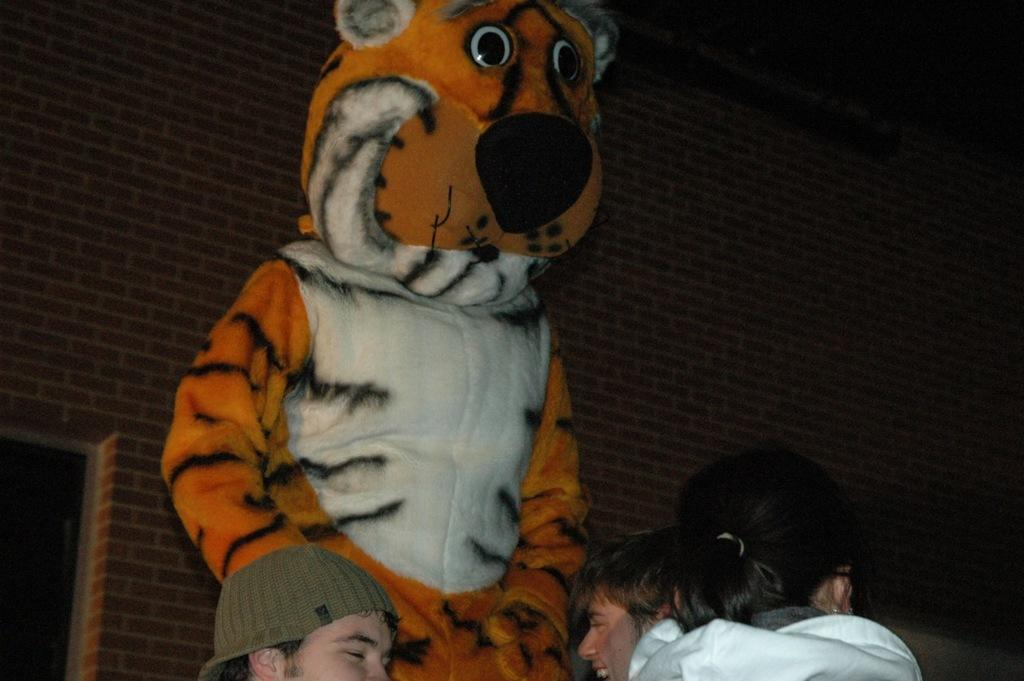What type of animal is in the image? There is a tiger in the image. Are there any people in the image? Yes, there is a woman and two men in the image. What is the facial expression of the men? The men are smiling. What can be seen in the background of the image? There are brick walls in the background of the image. What size of needle is being used by the tiger in the image? There is no needle present in the image, as it features a tiger, a woman, and two men. 